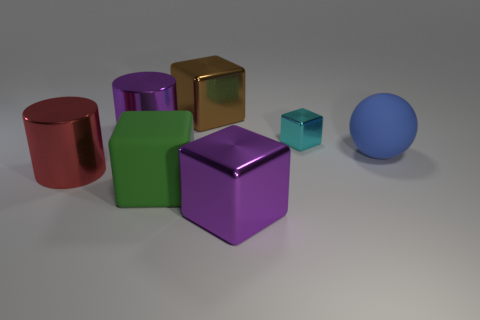Are there any other things that have the same size as the cyan block?
Make the answer very short. No. There is a brown object that is the same size as the blue rubber object; what is it made of?
Give a very brief answer. Metal. Is there a shiny object that has the same size as the blue matte thing?
Give a very brief answer. Yes. Are there fewer shiny things that are on the left side of the large red object than metallic cylinders?
Make the answer very short. Yes. Are there fewer brown metal objects to the left of the large purple cylinder than red shiny cylinders that are left of the brown shiny block?
Offer a very short reply. Yes. How many cylinders are either blue matte things or large red metal objects?
Offer a very short reply. 1. Are the purple object behind the large blue ball and the big cylinder in front of the big blue ball made of the same material?
Your answer should be compact. Yes. What shape is the red object that is the same size as the purple cylinder?
Your response must be concise. Cylinder. How many green things are either blocks or big metal blocks?
Your response must be concise. 1. There is a big rubber thing that is on the right side of the brown object; is its shape the same as the big thing that is in front of the green thing?
Your response must be concise. No. 